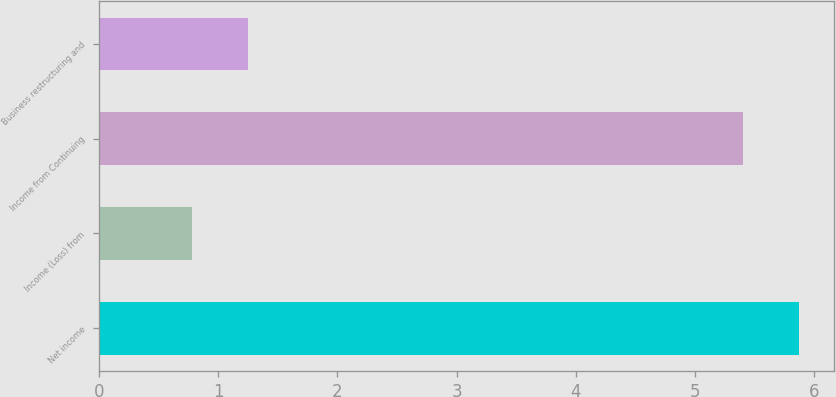Convert chart to OTSL. <chart><loc_0><loc_0><loc_500><loc_500><bar_chart><fcel>Net income<fcel>Income (Loss) from<fcel>Income from Continuing<fcel>Business restructuring and<nl><fcel>5.87<fcel>0.78<fcel>5.4<fcel>1.25<nl></chart> 